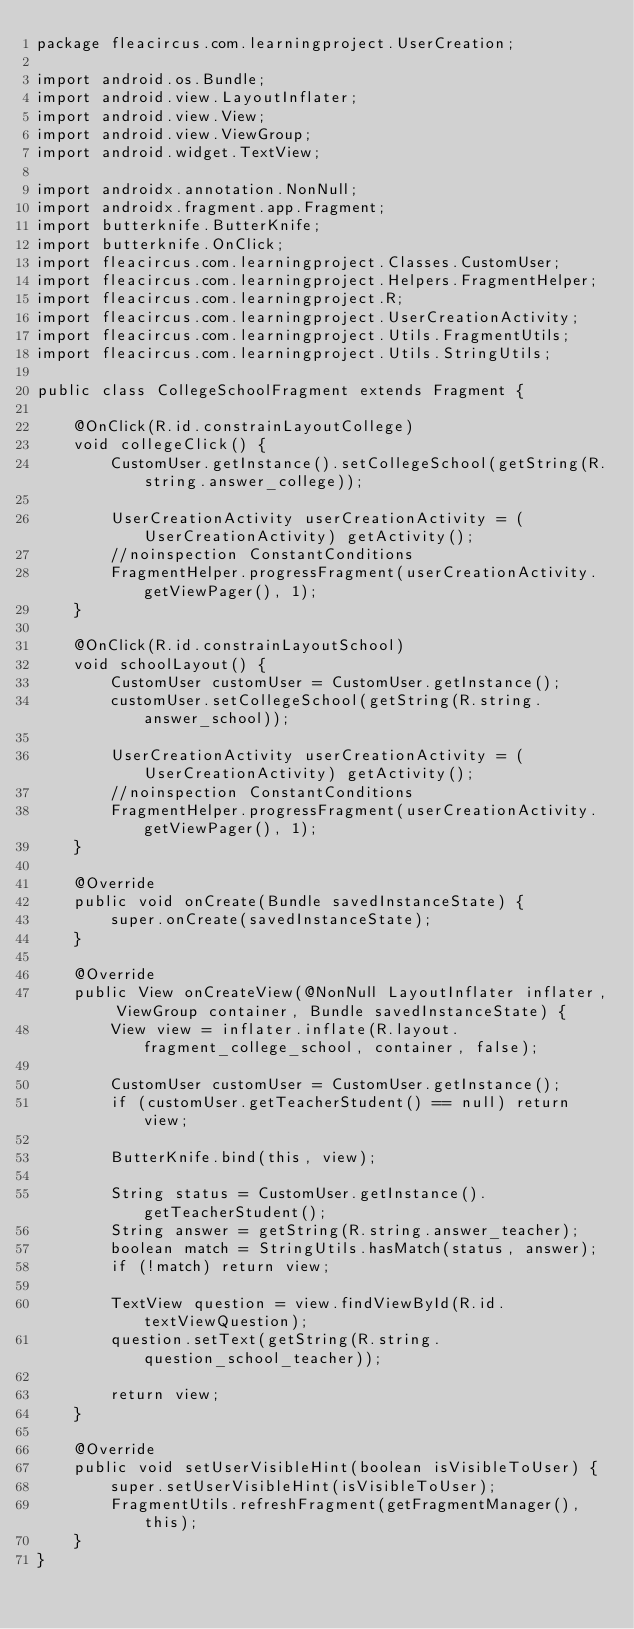Convert code to text. <code><loc_0><loc_0><loc_500><loc_500><_Java_>package fleacircus.com.learningproject.UserCreation;

import android.os.Bundle;
import android.view.LayoutInflater;
import android.view.View;
import android.view.ViewGroup;
import android.widget.TextView;

import androidx.annotation.NonNull;
import androidx.fragment.app.Fragment;
import butterknife.ButterKnife;
import butterknife.OnClick;
import fleacircus.com.learningproject.Classes.CustomUser;
import fleacircus.com.learningproject.Helpers.FragmentHelper;
import fleacircus.com.learningproject.R;
import fleacircus.com.learningproject.UserCreationActivity;
import fleacircus.com.learningproject.Utils.FragmentUtils;
import fleacircus.com.learningproject.Utils.StringUtils;

public class CollegeSchoolFragment extends Fragment {

    @OnClick(R.id.constrainLayoutCollege)
    void collegeClick() {
        CustomUser.getInstance().setCollegeSchool(getString(R.string.answer_college));

        UserCreationActivity userCreationActivity = (UserCreationActivity) getActivity();
        //noinspection ConstantConditions
        FragmentHelper.progressFragment(userCreationActivity.getViewPager(), 1);
    }

    @OnClick(R.id.constrainLayoutSchool)
    void schoolLayout() {
        CustomUser customUser = CustomUser.getInstance();
        customUser.setCollegeSchool(getString(R.string.answer_school));

        UserCreationActivity userCreationActivity = (UserCreationActivity) getActivity();
        //noinspection ConstantConditions
        FragmentHelper.progressFragment(userCreationActivity.getViewPager(), 1);
    }

    @Override
    public void onCreate(Bundle savedInstanceState) {
        super.onCreate(savedInstanceState);
    }

    @Override
    public View onCreateView(@NonNull LayoutInflater inflater, ViewGroup container, Bundle savedInstanceState) {
        View view = inflater.inflate(R.layout.fragment_college_school, container, false);

        CustomUser customUser = CustomUser.getInstance();
        if (customUser.getTeacherStudent() == null) return view;

        ButterKnife.bind(this, view);

        String status = CustomUser.getInstance().getTeacherStudent();
        String answer = getString(R.string.answer_teacher);
        boolean match = StringUtils.hasMatch(status, answer);
        if (!match) return view;

        TextView question = view.findViewById(R.id.textViewQuestion);
        question.setText(getString(R.string.question_school_teacher));

        return view;
    }

    @Override
    public void setUserVisibleHint(boolean isVisibleToUser) {
        super.setUserVisibleHint(isVisibleToUser);
        FragmentUtils.refreshFragment(getFragmentManager(), this);
    }
}</code> 